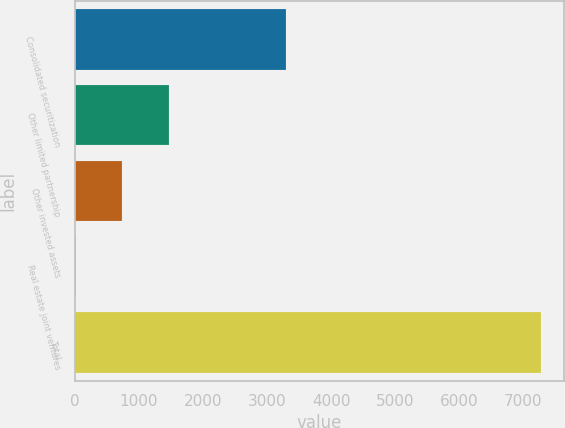Convert chart to OTSL. <chart><loc_0><loc_0><loc_500><loc_500><bar_chart><fcel>Consolidated securitization<fcel>Other limited partnership<fcel>Other invested assets<fcel>Real estate joint ventures<fcel>Total<nl><fcel>3299<fcel>1467.4<fcel>741.7<fcel>16<fcel>7273<nl></chart> 